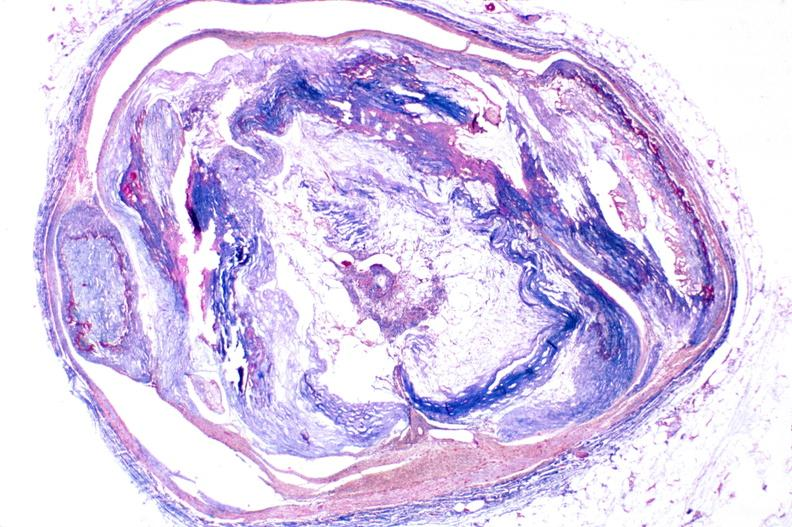what is present?
Answer the question using a single word or phrase. Cardiovascular 